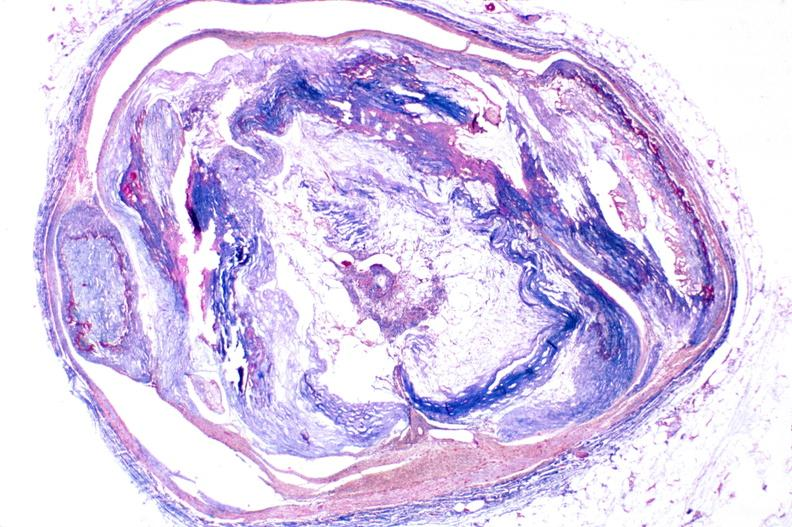what is present?
Answer the question using a single word or phrase. Cardiovascular 